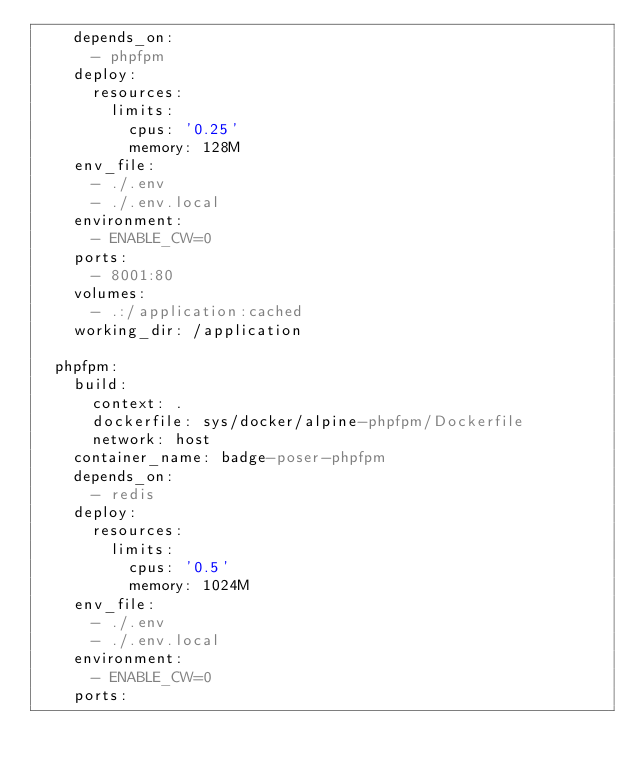<code> <loc_0><loc_0><loc_500><loc_500><_YAML_>    depends_on:
      - phpfpm
    deploy:
      resources:
        limits:
          cpus: '0.25'
          memory: 128M
    env_file:
      - ./.env
      - ./.env.local
    environment:
      - ENABLE_CW=0
    ports:
      - 8001:80
    volumes:
      - .:/application:cached
    working_dir: /application

  phpfpm:
    build:
      context: .
      dockerfile: sys/docker/alpine-phpfpm/Dockerfile
      network: host
    container_name: badge-poser-phpfpm
    depends_on:
      - redis
    deploy:
      resources:
        limits:
          cpus: '0.5'
          memory: 1024M
    env_file:
      - ./.env
      - ./.env.local
    environment:
      - ENABLE_CW=0
    ports:</code> 